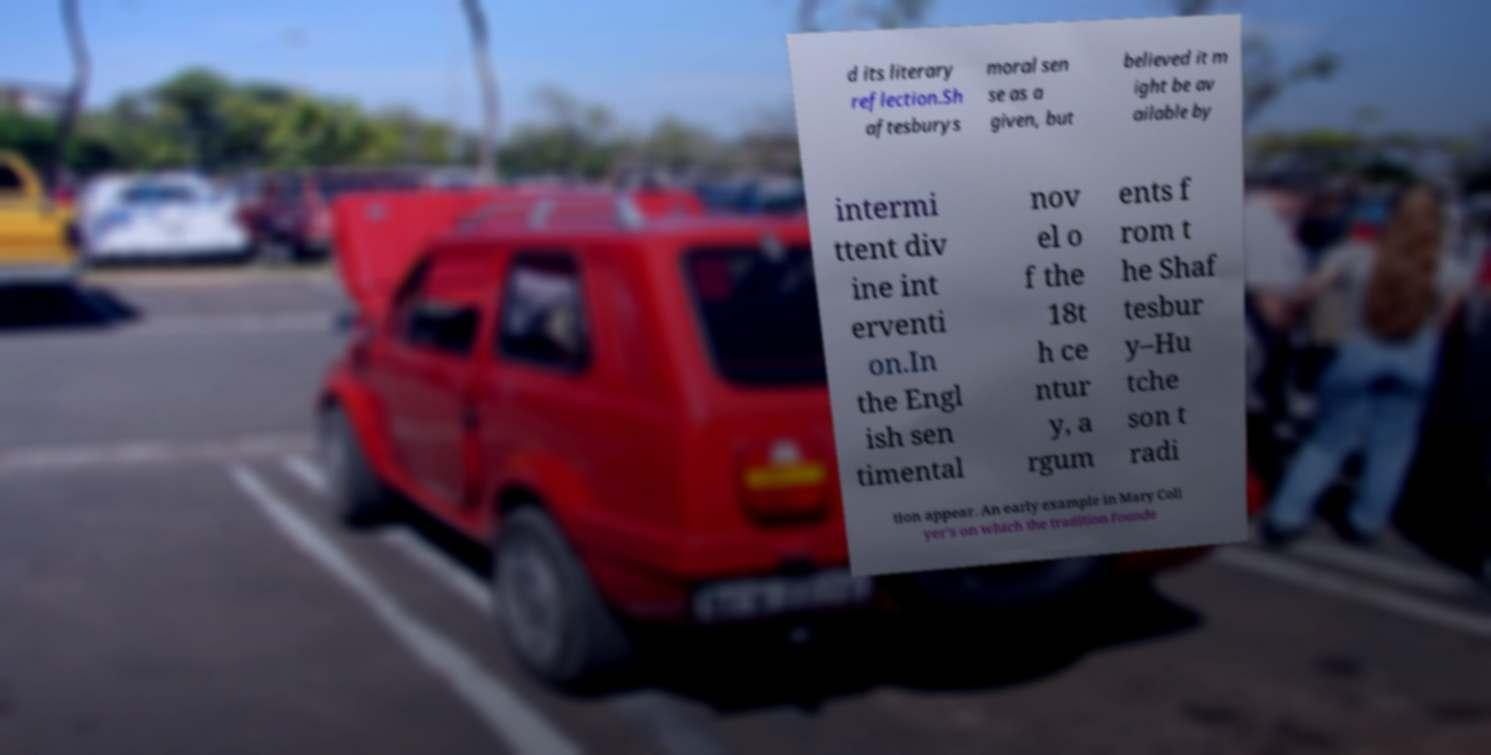Please identify and transcribe the text found in this image. d its literary reflection.Sh aftesburys moral sen se as a given, but believed it m ight be av ailable by intermi ttent div ine int erventi on.In the Engl ish sen timental nov el o f the 18t h ce ntur y, a rgum ents f rom t he Shaf tesbur y–Hu tche son t radi tion appear. An early example in Mary Coll yer's on which the tradition founde 